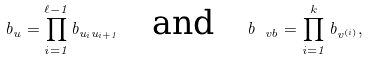<formula> <loc_0><loc_0><loc_500><loc_500>b _ { u } = \prod _ { i = 1 } ^ { \ell - 1 } b _ { u _ { i } u _ { i + 1 } } \quad \text {and} \quad b _ { \ v b } = \prod _ { i = 1 } ^ { k } b _ { v ^ { ( i ) } } ,</formula> 